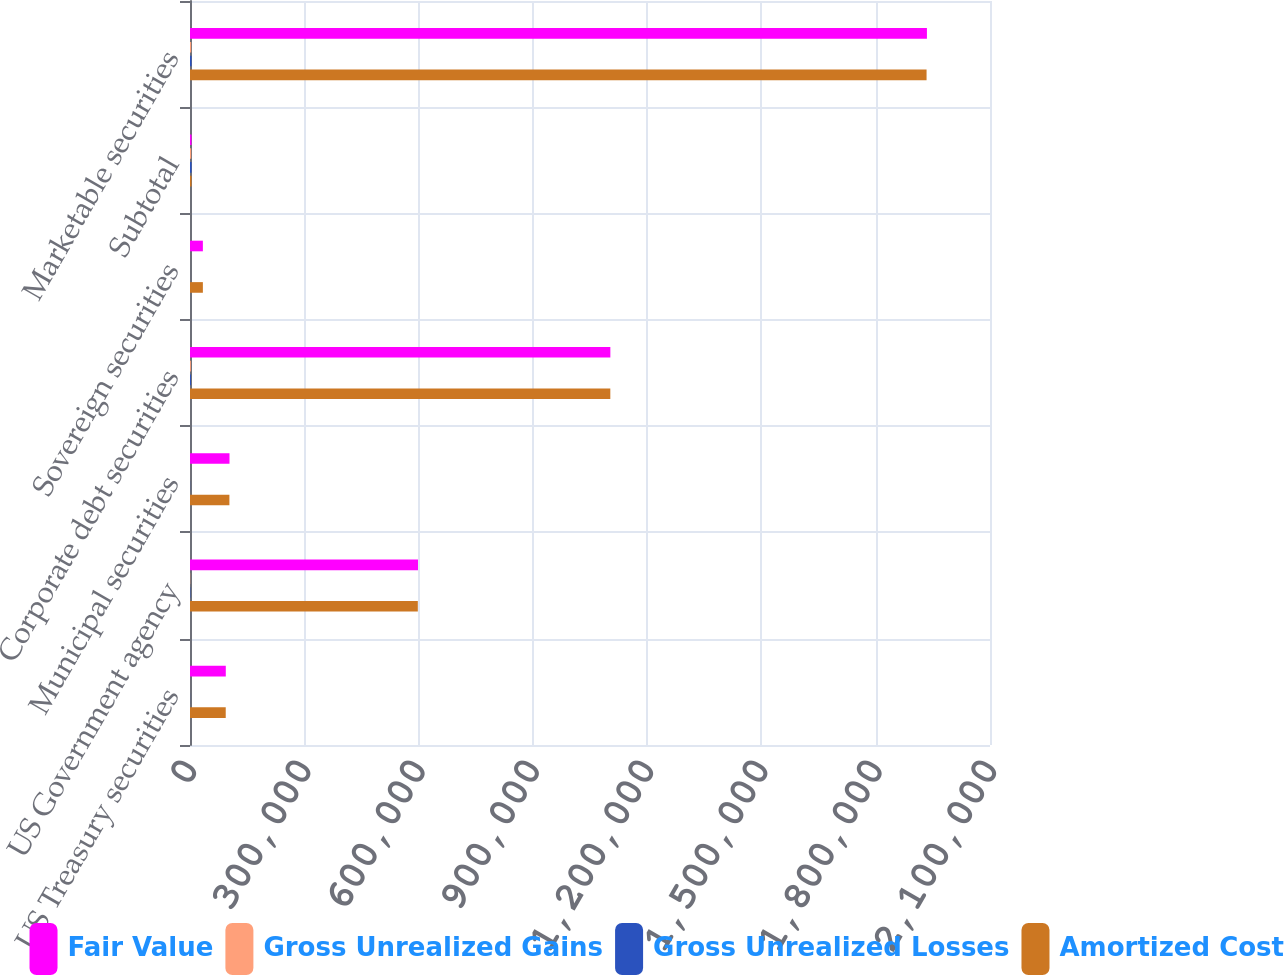<chart> <loc_0><loc_0><loc_500><loc_500><stacked_bar_chart><ecel><fcel>US Treasury securities<fcel>US Government agency<fcel>Municipal securities<fcel>Corporate debt securities<fcel>Sovereign securities<fcel>Subtotal<fcel>Marketable securities<nl><fcel>Fair Value<fcel>93940<fcel>598471<fcel>103686<fcel>1.10344e+06<fcel>33799<fcel>4002<fcel>1.93442e+06<nl><fcel>Gross Unrealized Gains<fcel>53<fcel>569<fcel>71<fcel>2353<fcel>25<fcel>3071<fcel>3071<nl><fcel>Gross Unrealized Losses<fcel>206<fcel>1009<fcel>302<fcel>2466<fcel>19<fcel>4002<fcel>4002<nl><fcel>Amortized Cost<fcel>93787<fcel>598031<fcel>103455<fcel>1.10332e+06<fcel>33805<fcel>4002<fcel>1.93349e+06<nl></chart> 